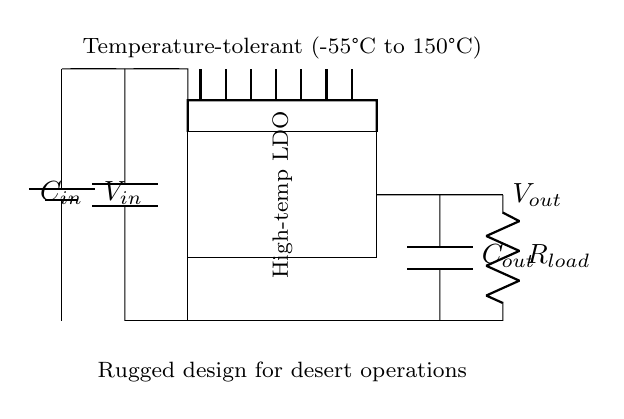What type of voltage regulator is used in this circuit? The circuit diagram specifically mentions a "High-temp LDO" which refers to a Low Dropout Regulator designed for high-temperature environments. Hence, the type of regulator is identified directly from the label within the circuit.
Answer: High-temperature LDO What is the function of the capacitor labeled C in the circuit? The circuit contains two capacitors, C_in and C_out. C_in is used for input smoothing and filtering, while C_out is for output stability and filtering. The labels next to the capacitors indicate their purpose, confirming their roles in the voltage regulation process.
Answer: Smoothing and filtering What temperature range can this voltage regulator tolerate? The circuit explicitly states "Temperature-tolerant (-55°C to 150°C)" near the voltage regulator, providing the temperature range that the device can operate within without failure.
Answer: -55°C to 150°C What component represents the load in this circuit? The resistor labeled R_load is directly connected to the output voltage terminal and typically represents the load in a voltage regulator setup; this is evident from its placement in the circuit and the labeling.
Answer: R_load How many components are involved between the input and output capacitor? By analyzing the circuit, we can see the input capacitor (C_in), the voltage regulator, and the output capacitor (C_out). So, we count C_in, the regulator, and C_out, totaling three components that facilitate the conversion from input to output.
Answer: Three components What is the purpose of the heat sink in the circuit? The circuit diagram illustrates a heat sink connected to the voltage regulator, which is intended to dissipate heat generated during operation. The need for temperature management in high-temperature applications is indicated by its presence near the regulator.
Answer: Heat dissipation What connection types are shown in the circuit besides capacitors and resistors? The circuit includes lines representing batteries, capacitors, and a regulator, but the specific question asks for connection types. There are both short and direct connections, indicating electrical paths between components; these connection types provide routes for current flow, as represented by the lines in the diagram.
Answer: Short and direct connections 